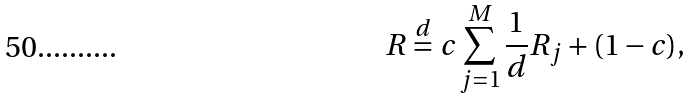Convert formula to latex. <formula><loc_0><loc_0><loc_500><loc_500>R \stackrel { d } = c \sum _ { j = 1 } ^ { M } \frac { 1 } { d } R _ { j } + ( 1 - c ) ,</formula> 